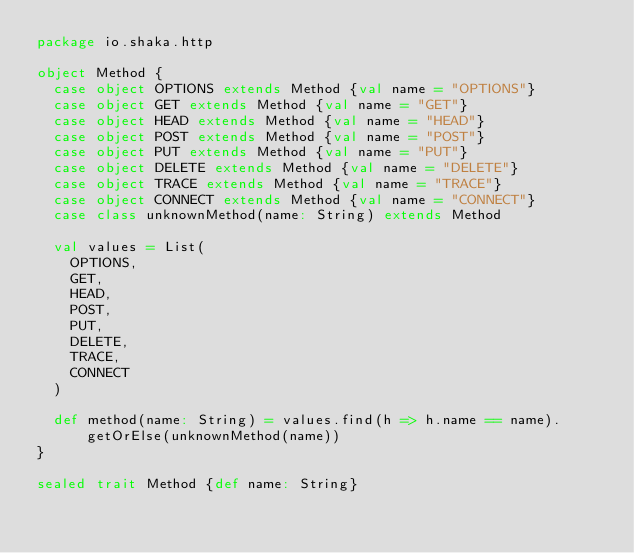Convert code to text. <code><loc_0><loc_0><loc_500><loc_500><_Scala_>package io.shaka.http

object Method {
  case object OPTIONS extends Method {val name = "OPTIONS"}
  case object GET extends Method {val name = "GET"}
  case object HEAD extends Method {val name = "HEAD"}
  case object POST extends Method {val name = "POST"}
  case object PUT extends Method {val name = "PUT"}
  case object DELETE extends Method {val name = "DELETE"}
  case object TRACE extends Method {val name = "TRACE"}
  case object CONNECT extends Method {val name = "CONNECT"}
  case class unknownMethod(name: String) extends Method

  val values = List(
    OPTIONS,
    GET,
    HEAD,
    POST,
    PUT,
    DELETE,
    TRACE,
    CONNECT
  )

  def method(name: String) = values.find(h => h.name == name).getOrElse(unknownMethod(name))
}

sealed trait Method {def name: String}</code> 